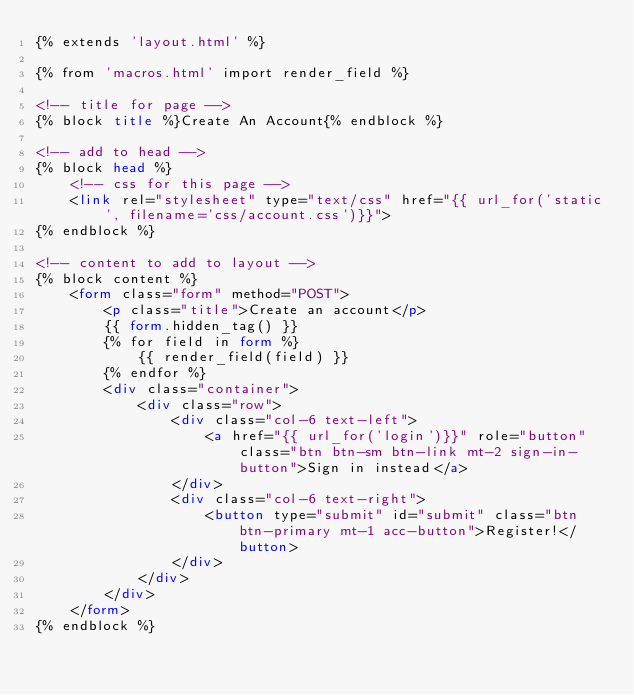Convert code to text. <code><loc_0><loc_0><loc_500><loc_500><_HTML_>{% extends 'layout.html' %}

{% from 'macros.html' import render_field %}

<!-- title for page -->
{% block title %}Create An Account{% endblock %}

<!-- add to head -->
{% block head %}
    <!-- css for this page -->
    <link rel="stylesheet" type="text/css" href="{{ url_for('static', filename='css/account.css')}}">
{% endblock %}

<!-- content to add to layout -->
{% block content %}
    <form class="form" method="POST">
        <p class="title">Create an account</p>
        {{ form.hidden_tag() }}
        {% for field in form %}
            {{ render_field(field) }}
        {% endfor %}
        <div class="container">
            <div class="row">
                <div class="col-6 text-left">
                    <a href="{{ url_for('login')}}" role="button" class="btn btn-sm btn-link mt-2 sign-in-button">Sign in instead</a>
                </div>
                <div class="col-6 text-right">
                    <button type="submit" id="submit" class="btn btn-primary mt-1 acc-button">Register!</button>
                </div>
            </div>
        </div>
    </form>
{% endblock %}</code> 